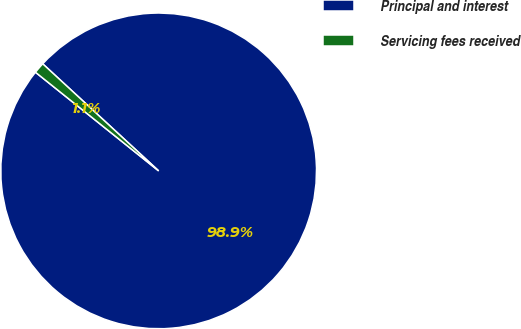<chart> <loc_0><loc_0><loc_500><loc_500><pie_chart><fcel>Principal and interest<fcel>Servicing fees received<nl><fcel>98.88%<fcel>1.12%<nl></chart> 